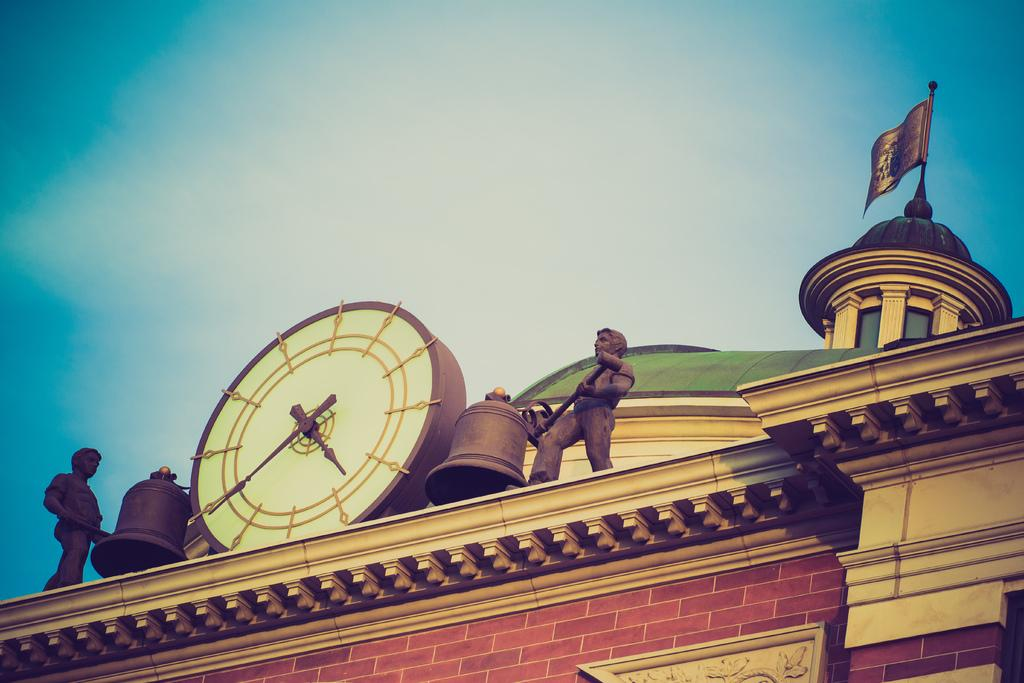What can be seen between the two statues in the image? There is a clock and bells between the two statues in the image. What type of structure is present in the image? There is a wall in the image. What is the purpose of the flag in the image? The flag's purpose is not specified in the image, but it may represent a country, organization, or event. What is visible in the background of the image? The sky is visible in the background of the image. What year is the lawyer mentioned in the image? There is no mention of a lawyer or any specific year in the image. Can you tell me how the moon looks in the image? The moon is not visible in the image; it only shows statues, a clock, bells, a wall, a flag, and the sky. 